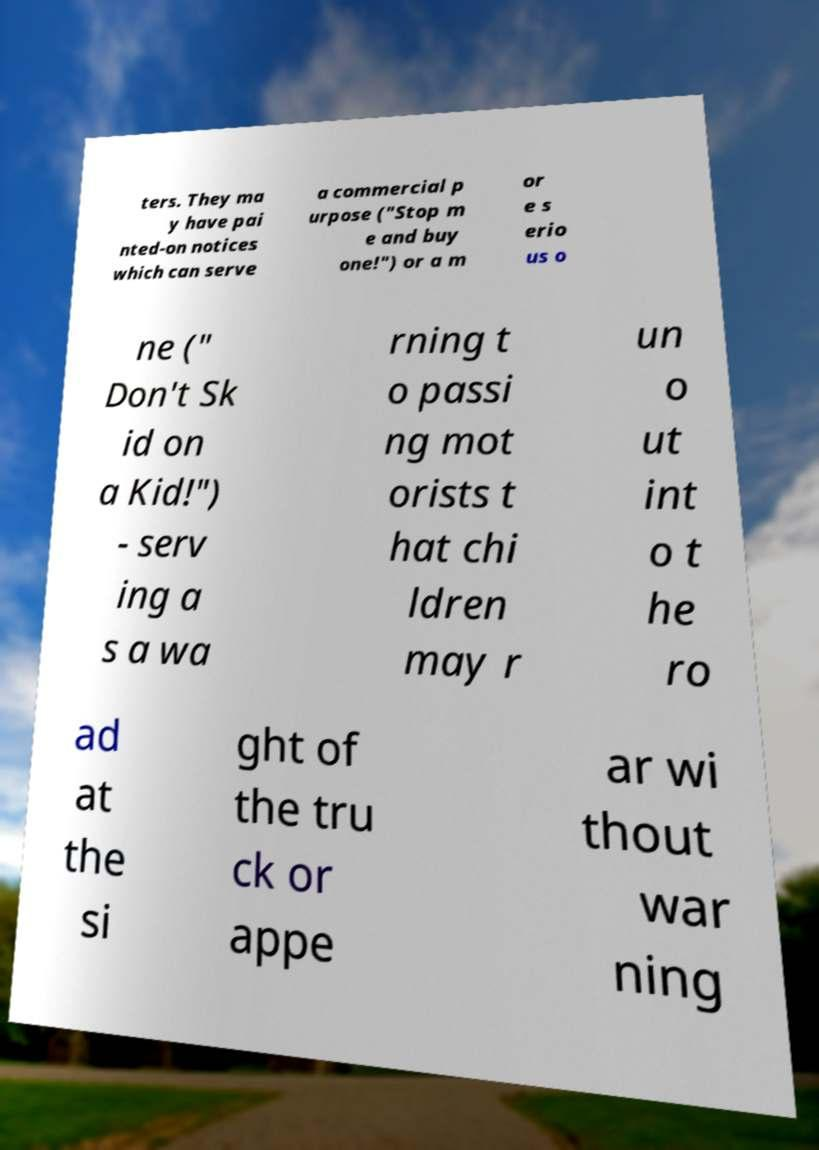Could you assist in decoding the text presented in this image and type it out clearly? ters. They ma y have pai nted-on notices which can serve a commercial p urpose ("Stop m e and buy one!") or a m or e s erio us o ne (" Don't Sk id on a Kid!") - serv ing a s a wa rning t o passi ng mot orists t hat chi ldren may r un o ut int o t he ro ad at the si ght of the tru ck or appe ar wi thout war ning 